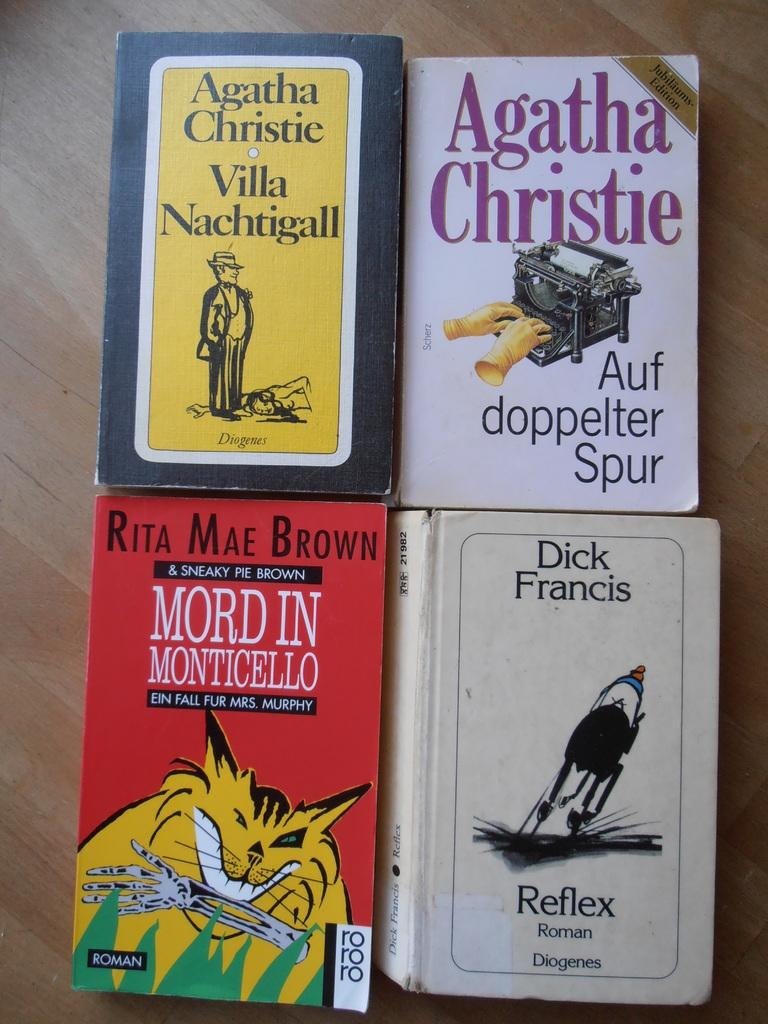<image>
Provide a brief description of the given image. Two Agatha Christie books lie on a table above two other novels. 